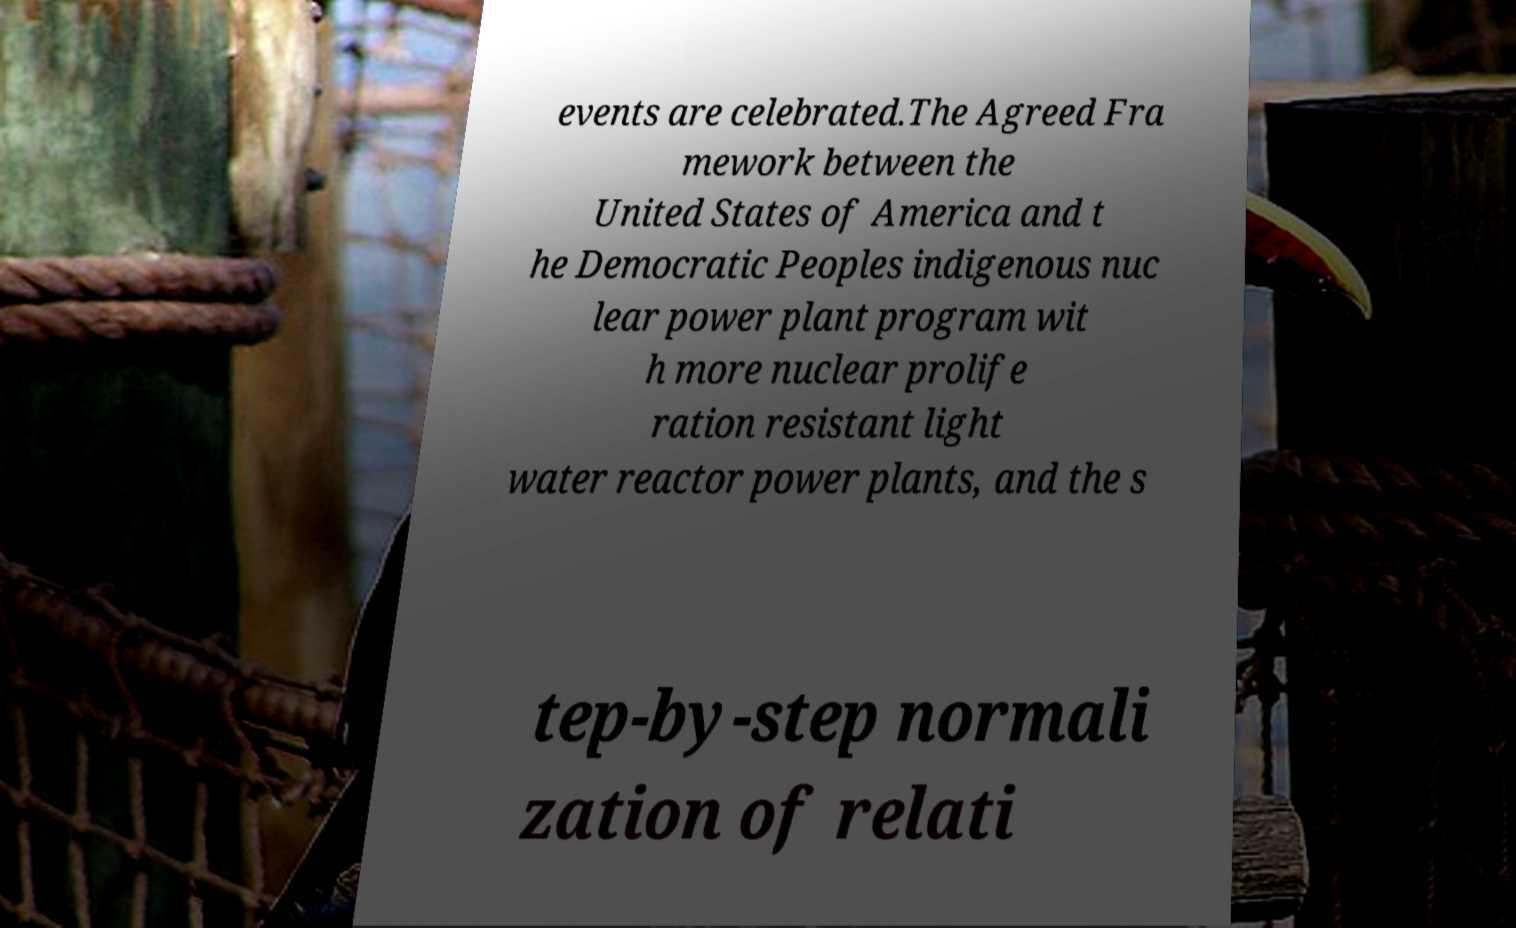Could you extract and type out the text from this image? events are celebrated.The Agreed Fra mework between the United States of America and t he Democratic Peoples indigenous nuc lear power plant program wit h more nuclear prolife ration resistant light water reactor power plants, and the s tep-by-step normali zation of relati 